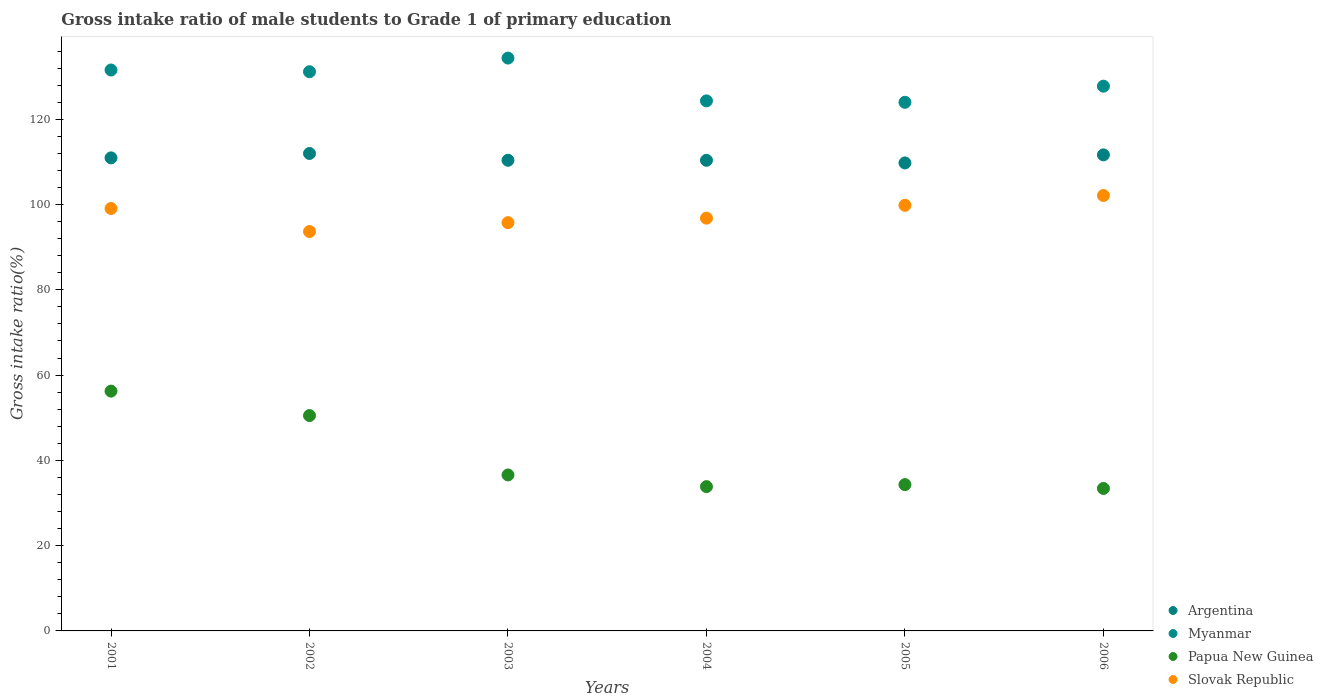How many different coloured dotlines are there?
Your response must be concise. 4. What is the gross intake ratio in Slovak Republic in 2005?
Offer a very short reply. 99.82. Across all years, what is the maximum gross intake ratio in Myanmar?
Offer a very short reply. 134.35. Across all years, what is the minimum gross intake ratio in Papua New Guinea?
Keep it short and to the point. 33.41. In which year was the gross intake ratio in Slovak Republic maximum?
Offer a very short reply. 2006. In which year was the gross intake ratio in Slovak Republic minimum?
Ensure brevity in your answer.  2002. What is the total gross intake ratio in Papua New Guinea in the graph?
Make the answer very short. 244.9. What is the difference between the gross intake ratio in Myanmar in 2002 and that in 2005?
Provide a succinct answer. 7.17. What is the difference between the gross intake ratio in Argentina in 2003 and the gross intake ratio in Myanmar in 2001?
Your answer should be compact. -21.17. What is the average gross intake ratio in Myanmar per year?
Provide a succinct answer. 128.85. In the year 2004, what is the difference between the gross intake ratio in Papua New Guinea and gross intake ratio in Slovak Republic?
Your answer should be very brief. -62.97. In how many years, is the gross intake ratio in Slovak Republic greater than 132 %?
Your response must be concise. 0. What is the ratio of the gross intake ratio in Myanmar in 2004 to that in 2005?
Your answer should be very brief. 1. What is the difference between the highest and the second highest gross intake ratio in Argentina?
Your answer should be very brief. 0.33. What is the difference between the highest and the lowest gross intake ratio in Slovak Republic?
Your answer should be compact. 8.45. In how many years, is the gross intake ratio in Myanmar greater than the average gross intake ratio in Myanmar taken over all years?
Offer a terse response. 3. Is the sum of the gross intake ratio in Papua New Guinea in 2002 and 2005 greater than the maximum gross intake ratio in Myanmar across all years?
Give a very brief answer. No. Is it the case that in every year, the sum of the gross intake ratio in Myanmar and gross intake ratio in Argentina  is greater than the sum of gross intake ratio in Slovak Republic and gross intake ratio in Papua New Guinea?
Your answer should be very brief. Yes. What is the difference between two consecutive major ticks on the Y-axis?
Ensure brevity in your answer.  20. Does the graph contain grids?
Provide a short and direct response. No. What is the title of the graph?
Offer a very short reply. Gross intake ratio of male students to Grade 1 of primary education. Does "Norway" appear as one of the legend labels in the graph?
Offer a very short reply. No. What is the label or title of the Y-axis?
Provide a short and direct response. Gross intake ratio(%). What is the Gross intake ratio(%) of Argentina in 2001?
Provide a short and direct response. 110.95. What is the Gross intake ratio(%) of Myanmar in 2001?
Ensure brevity in your answer.  131.56. What is the Gross intake ratio(%) of Papua New Guinea in 2001?
Keep it short and to the point. 56.24. What is the Gross intake ratio(%) in Slovak Republic in 2001?
Make the answer very short. 99.08. What is the Gross intake ratio(%) of Argentina in 2002?
Make the answer very short. 111.98. What is the Gross intake ratio(%) in Myanmar in 2002?
Offer a very short reply. 131.15. What is the Gross intake ratio(%) of Papua New Guinea in 2002?
Your response must be concise. 50.51. What is the Gross intake ratio(%) of Slovak Republic in 2002?
Provide a short and direct response. 93.67. What is the Gross intake ratio(%) in Argentina in 2003?
Ensure brevity in your answer.  110.39. What is the Gross intake ratio(%) in Myanmar in 2003?
Provide a succinct answer. 134.35. What is the Gross intake ratio(%) in Papua New Guinea in 2003?
Offer a terse response. 36.58. What is the Gross intake ratio(%) of Slovak Republic in 2003?
Give a very brief answer. 95.75. What is the Gross intake ratio(%) in Argentina in 2004?
Offer a terse response. 110.38. What is the Gross intake ratio(%) of Myanmar in 2004?
Give a very brief answer. 124.32. What is the Gross intake ratio(%) of Papua New Guinea in 2004?
Your response must be concise. 33.84. What is the Gross intake ratio(%) in Slovak Republic in 2004?
Provide a short and direct response. 96.81. What is the Gross intake ratio(%) of Argentina in 2005?
Offer a terse response. 109.76. What is the Gross intake ratio(%) in Myanmar in 2005?
Your answer should be very brief. 123.98. What is the Gross intake ratio(%) in Papua New Guinea in 2005?
Offer a very short reply. 34.31. What is the Gross intake ratio(%) of Slovak Republic in 2005?
Keep it short and to the point. 99.82. What is the Gross intake ratio(%) of Argentina in 2006?
Make the answer very short. 111.65. What is the Gross intake ratio(%) of Myanmar in 2006?
Give a very brief answer. 127.77. What is the Gross intake ratio(%) of Papua New Guinea in 2006?
Offer a very short reply. 33.41. What is the Gross intake ratio(%) of Slovak Republic in 2006?
Your answer should be compact. 102.12. Across all years, what is the maximum Gross intake ratio(%) in Argentina?
Provide a short and direct response. 111.98. Across all years, what is the maximum Gross intake ratio(%) of Myanmar?
Your answer should be compact. 134.35. Across all years, what is the maximum Gross intake ratio(%) in Papua New Guinea?
Your response must be concise. 56.24. Across all years, what is the maximum Gross intake ratio(%) in Slovak Republic?
Your response must be concise. 102.12. Across all years, what is the minimum Gross intake ratio(%) in Argentina?
Make the answer very short. 109.76. Across all years, what is the minimum Gross intake ratio(%) in Myanmar?
Keep it short and to the point. 123.98. Across all years, what is the minimum Gross intake ratio(%) in Papua New Guinea?
Your response must be concise. 33.41. Across all years, what is the minimum Gross intake ratio(%) in Slovak Republic?
Provide a short and direct response. 93.67. What is the total Gross intake ratio(%) in Argentina in the graph?
Give a very brief answer. 665.11. What is the total Gross intake ratio(%) of Myanmar in the graph?
Ensure brevity in your answer.  773.12. What is the total Gross intake ratio(%) of Papua New Guinea in the graph?
Provide a short and direct response. 244.9. What is the total Gross intake ratio(%) in Slovak Republic in the graph?
Offer a terse response. 587.25. What is the difference between the Gross intake ratio(%) of Argentina in 2001 and that in 2002?
Make the answer very short. -1.03. What is the difference between the Gross intake ratio(%) of Myanmar in 2001 and that in 2002?
Provide a succinct answer. 0.4. What is the difference between the Gross intake ratio(%) in Papua New Guinea in 2001 and that in 2002?
Ensure brevity in your answer.  5.73. What is the difference between the Gross intake ratio(%) of Slovak Republic in 2001 and that in 2002?
Your answer should be very brief. 5.41. What is the difference between the Gross intake ratio(%) of Argentina in 2001 and that in 2003?
Give a very brief answer. 0.56. What is the difference between the Gross intake ratio(%) in Myanmar in 2001 and that in 2003?
Provide a short and direct response. -2.8. What is the difference between the Gross intake ratio(%) in Papua New Guinea in 2001 and that in 2003?
Make the answer very short. 19.66. What is the difference between the Gross intake ratio(%) of Slovak Republic in 2001 and that in 2003?
Ensure brevity in your answer.  3.32. What is the difference between the Gross intake ratio(%) in Argentina in 2001 and that in 2004?
Make the answer very short. 0.57. What is the difference between the Gross intake ratio(%) in Myanmar in 2001 and that in 2004?
Offer a terse response. 7.24. What is the difference between the Gross intake ratio(%) in Papua New Guinea in 2001 and that in 2004?
Provide a succinct answer. 22.4. What is the difference between the Gross intake ratio(%) of Slovak Republic in 2001 and that in 2004?
Keep it short and to the point. 2.27. What is the difference between the Gross intake ratio(%) of Argentina in 2001 and that in 2005?
Provide a succinct answer. 1.19. What is the difference between the Gross intake ratio(%) in Myanmar in 2001 and that in 2005?
Your response must be concise. 7.57. What is the difference between the Gross intake ratio(%) of Papua New Guinea in 2001 and that in 2005?
Provide a succinct answer. 21.93. What is the difference between the Gross intake ratio(%) of Slovak Republic in 2001 and that in 2005?
Offer a terse response. -0.75. What is the difference between the Gross intake ratio(%) in Argentina in 2001 and that in 2006?
Provide a short and direct response. -0.7. What is the difference between the Gross intake ratio(%) in Myanmar in 2001 and that in 2006?
Your response must be concise. 3.79. What is the difference between the Gross intake ratio(%) in Papua New Guinea in 2001 and that in 2006?
Ensure brevity in your answer.  22.83. What is the difference between the Gross intake ratio(%) in Slovak Republic in 2001 and that in 2006?
Your answer should be compact. -3.05. What is the difference between the Gross intake ratio(%) in Argentina in 2002 and that in 2003?
Provide a short and direct response. 1.6. What is the difference between the Gross intake ratio(%) of Myanmar in 2002 and that in 2003?
Keep it short and to the point. -3.2. What is the difference between the Gross intake ratio(%) of Papua New Guinea in 2002 and that in 2003?
Your answer should be compact. 13.93. What is the difference between the Gross intake ratio(%) in Slovak Republic in 2002 and that in 2003?
Offer a very short reply. -2.08. What is the difference between the Gross intake ratio(%) in Argentina in 2002 and that in 2004?
Your response must be concise. 1.6. What is the difference between the Gross intake ratio(%) in Myanmar in 2002 and that in 2004?
Ensure brevity in your answer.  6.84. What is the difference between the Gross intake ratio(%) of Papua New Guinea in 2002 and that in 2004?
Give a very brief answer. 16.67. What is the difference between the Gross intake ratio(%) of Slovak Republic in 2002 and that in 2004?
Ensure brevity in your answer.  -3.14. What is the difference between the Gross intake ratio(%) of Argentina in 2002 and that in 2005?
Make the answer very short. 2.22. What is the difference between the Gross intake ratio(%) in Myanmar in 2002 and that in 2005?
Provide a short and direct response. 7.17. What is the difference between the Gross intake ratio(%) of Papua New Guinea in 2002 and that in 2005?
Make the answer very short. 16.2. What is the difference between the Gross intake ratio(%) of Slovak Republic in 2002 and that in 2005?
Provide a short and direct response. -6.15. What is the difference between the Gross intake ratio(%) in Argentina in 2002 and that in 2006?
Keep it short and to the point. 0.33. What is the difference between the Gross intake ratio(%) in Myanmar in 2002 and that in 2006?
Your answer should be compact. 3.39. What is the difference between the Gross intake ratio(%) in Papua New Guinea in 2002 and that in 2006?
Offer a terse response. 17.1. What is the difference between the Gross intake ratio(%) of Slovak Republic in 2002 and that in 2006?
Keep it short and to the point. -8.45. What is the difference between the Gross intake ratio(%) of Argentina in 2003 and that in 2004?
Your answer should be compact. 0.01. What is the difference between the Gross intake ratio(%) of Myanmar in 2003 and that in 2004?
Offer a terse response. 10.04. What is the difference between the Gross intake ratio(%) in Papua New Guinea in 2003 and that in 2004?
Offer a terse response. 2.74. What is the difference between the Gross intake ratio(%) in Slovak Republic in 2003 and that in 2004?
Make the answer very short. -1.06. What is the difference between the Gross intake ratio(%) of Argentina in 2003 and that in 2005?
Offer a very short reply. 0.63. What is the difference between the Gross intake ratio(%) of Myanmar in 2003 and that in 2005?
Provide a short and direct response. 10.37. What is the difference between the Gross intake ratio(%) in Papua New Guinea in 2003 and that in 2005?
Your answer should be compact. 2.27. What is the difference between the Gross intake ratio(%) in Slovak Republic in 2003 and that in 2005?
Offer a terse response. -4.07. What is the difference between the Gross intake ratio(%) in Argentina in 2003 and that in 2006?
Make the answer very short. -1.27. What is the difference between the Gross intake ratio(%) of Myanmar in 2003 and that in 2006?
Offer a terse response. 6.58. What is the difference between the Gross intake ratio(%) in Papua New Guinea in 2003 and that in 2006?
Your answer should be very brief. 3.17. What is the difference between the Gross intake ratio(%) of Slovak Republic in 2003 and that in 2006?
Keep it short and to the point. -6.37. What is the difference between the Gross intake ratio(%) of Argentina in 2004 and that in 2005?
Ensure brevity in your answer.  0.62. What is the difference between the Gross intake ratio(%) of Myanmar in 2004 and that in 2005?
Provide a short and direct response. 0.33. What is the difference between the Gross intake ratio(%) of Papua New Guinea in 2004 and that in 2005?
Keep it short and to the point. -0.47. What is the difference between the Gross intake ratio(%) in Slovak Republic in 2004 and that in 2005?
Provide a succinct answer. -3.01. What is the difference between the Gross intake ratio(%) in Argentina in 2004 and that in 2006?
Provide a succinct answer. -1.27. What is the difference between the Gross intake ratio(%) in Myanmar in 2004 and that in 2006?
Your answer should be very brief. -3.45. What is the difference between the Gross intake ratio(%) of Papua New Guinea in 2004 and that in 2006?
Ensure brevity in your answer.  0.43. What is the difference between the Gross intake ratio(%) of Slovak Republic in 2004 and that in 2006?
Keep it short and to the point. -5.31. What is the difference between the Gross intake ratio(%) of Argentina in 2005 and that in 2006?
Provide a short and direct response. -1.89. What is the difference between the Gross intake ratio(%) of Myanmar in 2005 and that in 2006?
Provide a short and direct response. -3.78. What is the difference between the Gross intake ratio(%) of Papua New Guinea in 2005 and that in 2006?
Ensure brevity in your answer.  0.9. What is the difference between the Gross intake ratio(%) of Slovak Republic in 2005 and that in 2006?
Give a very brief answer. -2.3. What is the difference between the Gross intake ratio(%) in Argentina in 2001 and the Gross intake ratio(%) in Myanmar in 2002?
Make the answer very short. -20.2. What is the difference between the Gross intake ratio(%) of Argentina in 2001 and the Gross intake ratio(%) of Papua New Guinea in 2002?
Provide a short and direct response. 60.44. What is the difference between the Gross intake ratio(%) of Argentina in 2001 and the Gross intake ratio(%) of Slovak Republic in 2002?
Ensure brevity in your answer.  17.28. What is the difference between the Gross intake ratio(%) of Myanmar in 2001 and the Gross intake ratio(%) of Papua New Guinea in 2002?
Your answer should be very brief. 81.04. What is the difference between the Gross intake ratio(%) of Myanmar in 2001 and the Gross intake ratio(%) of Slovak Republic in 2002?
Provide a succinct answer. 37.89. What is the difference between the Gross intake ratio(%) in Papua New Guinea in 2001 and the Gross intake ratio(%) in Slovak Republic in 2002?
Offer a terse response. -37.43. What is the difference between the Gross intake ratio(%) in Argentina in 2001 and the Gross intake ratio(%) in Myanmar in 2003?
Your response must be concise. -23.4. What is the difference between the Gross intake ratio(%) of Argentina in 2001 and the Gross intake ratio(%) of Papua New Guinea in 2003?
Your response must be concise. 74.37. What is the difference between the Gross intake ratio(%) of Argentina in 2001 and the Gross intake ratio(%) of Slovak Republic in 2003?
Keep it short and to the point. 15.2. What is the difference between the Gross intake ratio(%) of Myanmar in 2001 and the Gross intake ratio(%) of Papua New Guinea in 2003?
Offer a very short reply. 94.98. What is the difference between the Gross intake ratio(%) of Myanmar in 2001 and the Gross intake ratio(%) of Slovak Republic in 2003?
Your answer should be very brief. 35.8. What is the difference between the Gross intake ratio(%) of Papua New Guinea in 2001 and the Gross intake ratio(%) of Slovak Republic in 2003?
Provide a short and direct response. -39.51. What is the difference between the Gross intake ratio(%) of Argentina in 2001 and the Gross intake ratio(%) of Myanmar in 2004?
Offer a terse response. -13.37. What is the difference between the Gross intake ratio(%) of Argentina in 2001 and the Gross intake ratio(%) of Papua New Guinea in 2004?
Offer a terse response. 77.11. What is the difference between the Gross intake ratio(%) in Argentina in 2001 and the Gross intake ratio(%) in Slovak Republic in 2004?
Provide a succinct answer. 14.14. What is the difference between the Gross intake ratio(%) in Myanmar in 2001 and the Gross intake ratio(%) in Papua New Guinea in 2004?
Ensure brevity in your answer.  97.72. What is the difference between the Gross intake ratio(%) of Myanmar in 2001 and the Gross intake ratio(%) of Slovak Republic in 2004?
Offer a very short reply. 34.74. What is the difference between the Gross intake ratio(%) in Papua New Guinea in 2001 and the Gross intake ratio(%) in Slovak Republic in 2004?
Your answer should be compact. -40.57. What is the difference between the Gross intake ratio(%) in Argentina in 2001 and the Gross intake ratio(%) in Myanmar in 2005?
Make the answer very short. -13.03. What is the difference between the Gross intake ratio(%) in Argentina in 2001 and the Gross intake ratio(%) in Papua New Guinea in 2005?
Your answer should be very brief. 76.63. What is the difference between the Gross intake ratio(%) of Argentina in 2001 and the Gross intake ratio(%) of Slovak Republic in 2005?
Provide a succinct answer. 11.13. What is the difference between the Gross intake ratio(%) in Myanmar in 2001 and the Gross intake ratio(%) in Papua New Guinea in 2005?
Your response must be concise. 97.24. What is the difference between the Gross intake ratio(%) in Myanmar in 2001 and the Gross intake ratio(%) in Slovak Republic in 2005?
Ensure brevity in your answer.  31.73. What is the difference between the Gross intake ratio(%) in Papua New Guinea in 2001 and the Gross intake ratio(%) in Slovak Republic in 2005?
Ensure brevity in your answer.  -43.58. What is the difference between the Gross intake ratio(%) of Argentina in 2001 and the Gross intake ratio(%) of Myanmar in 2006?
Offer a very short reply. -16.82. What is the difference between the Gross intake ratio(%) of Argentina in 2001 and the Gross intake ratio(%) of Papua New Guinea in 2006?
Make the answer very short. 77.54. What is the difference between the Gross intake ratio(%) of Argentina in 2001 and the Gross intake ratio(%) of Slovak Republic in 2006?
Your response must be concise. 8.83. What is the difference between the Gross intake ratio(%) in Myanmar in 2001 and the Gross intake ratio(%) in Papua New Guinea in 2006?
Keep it short and to the point. 98.14. What is the difference between the Gross intake ratio(%) in Myanmar in 2001 and the Gross intake ratio(%) in Slovak Republic in 2006?
Give a very brief answer. 29.43. What is the difference between the Gross intake ratio(%) in Papua New Guinea in 2001 and the Gross intake ratio(%) in Slovak Republic in 2006?
Your response must be concise. -45.88. What is the difference between the Gross intake ratio(%) in Argentina in 2002 and the Gross intake ratio(%) in Myanmar in 2003?
Provide a succinct answer. -22.37. What is the difference between the Gross intake ratio(%) of Argentina in 2002 and the Gross intake ratio(%) of Papua New Guinea in 2003?
Provide a short and direct response. 75.4. What is the difference between the Gross intake ratio(%) of Argentina in 2002 and the Gross intake ratio(%) of Slovak Republic in 2003?
Provide a succinct answer. 16.23. What is the difference between the Gross intake ratio(%) in Myanmar in 2002 and the Gross intake ratio(%) in Papua New Guinea in 2003?
Keep it short and to the point. 94.57. What is the difference between the Gross intake ratio(%) in Myanmar in 2002 and the Gross intake ratio(%) in Slovak Republic in 2003?
Offer a terse response. 35.4. What is the difference between the Gross intake ratio(%) in Papua New Guinea in 2002 and the Gross intake ratio(%) in Slovak Republic in 2003?
Your response must be concise. -45.24. What is the difference between the Gross intake ratio(%) of Argentina in 2002 and the Gross intake ratio(%) of Myanmar in 2004?
Offer a very short reply. -12.33. What is the difference between the Gross intake ratio(%) of Argentina in 2002 and the Gross intake ratio(%) of Papua New Guinea in 2004?
Keep it short and to the point. 78.14. What is the difference between the Gross intake ratio(%) in Argentina in 2002 and the Gross intake ratio(%) in Slovak Republic in 2004?
Your answer should be very brief. 15.17. What is the difference between the Gross intake ratio(%) in Myanmar in 2002 and the Gross intake ratio(%) in Papua New Guinea in 2004?
Keep it short and to the point. 97.31. What is the difference between the Gross intake ratio(%) in Myanmar in 2002 and the Gross intake ratio(%) in Slovak Republic in 2004?
Provide a short and direct response. 34.34. What is the difference between the Gross intake ratio(%) in Papua New Guinea in 2002 and the Gross intake ratio(%) in Slovak Republic in 2004?
Provide a succinct answer. -46.3. What is the difference between the Gross intake ratio(%) of Argentina in 2002 and the Gross intake ratio(%) of Myanmar in 2005?
Provide a short and direct response. -12. What is the difference between the Gross intake ratio(%) in Argentina in 2002 and the Gross intake ratio(%) in Papua New Guinea in 2005?
Your answer should be compact. 77.67. What is the difference between the Gross intake ratio(%) in Argentina in 2002 and the Gross intake ratio(%) in Slovak Republic in 2005?
Keep it short and to the point. 12.16. What is the difference between the Gross intake ratio(%) of Myanmar in 2002 and the Gross intake ratio(%) of Papua New Guinea in 2005?
Your answer should be compact. 96.84. What is the difference between the Gross intake ratio(%) in Myanmar in 2002 and the Gross intake ratio(%) in Slovak Republic in 2005?
Your response must be concise. 31.33. What is the difference between the Gross intake ratio(%) in Papua New Guinea in 2002 and the Gross intake ratio(%) in Slovak Republic in 2005?
Your response must be concise. -49.31. What is the difference between the Gross intake ratio(%) in Argentina in 2002 and the Gross intake ratio(%) in Myanmar in 2006?
Give a very brief answer. -15.78. What is the difference between the Gross intake ratio(%) in Argentina in 2002 and the Gross intake ratio(%) in Papua New Guinea in 2006?
Offer a very short reply. 78.57. What is the difference between the Gross intake ratio(%) in Argentina in 2002 and the Gross intake ratio(%) in Slovak Republic in 2006?
Give a very brief answer. 9.86. What is the difference between the Gross intake ratio(%) in Myanmar in 2002 and the Gross intake ratio(%) in Papua New Guinea in 2006?
Provide a succinct answer. 97.74. What is the difference between the Gross intake ratio(%) of Myanmar in 2002 and the Gross intake ratio(%) of Slovak Republic in 2006?
Offer a terse response. 29.03. What is the difference between the Gross intake ratio(%) of Papua New Guinea in 2002 and the Gross intake ratio(%) of Slovak Republic in 2006?
Offer a terse response. -51.61. What is the difference between the Gross intake ratio(%) in Argentina in 2003 and the Gross intake ratio(%) in Myanmar in 2004?
Offer a terse response. -13.93. What is the difference between the Gross intake ratio(%) in Argentina in 2003 and the Gross intake ratio(%) in Papua New Guinea in 2004?
Offer a terse response. 76.55. What is the difference between the Gross intake ratio(%) of Argentina in 2003 and the Gross intake ratio(%) of Slovak Republic in 2004?
Offer a terse response. 13.58. What is the difference between the Gross intake ratio(%) in Myanmar in 2003 and the Gross intake ratio(%) in Papua New Guinea in 2004?
Your answer should be very brief. 100.51. What is the difference between the Gross intake ratio(%) in Myanmar in 2003 and the Gross intake ratio(%) in Slovak Republic in 2004?
Offer a terse response. 37.54. What is the difference between the Gross intake ratio(%) in Papua New Guinea in 2003 and the Gross intake ratio(%) in Slovak Republic in 2004?
Make the answer very short. -60.23. What is the difference between the Gross intake ratio(%) in Argentina in 2003 and the Gross intake ratio(%) in Myanmar in 2005?
Give a very brief answer. -13.59. What is the difference between the Gross intake ratio(%) of Argentina in 2003 and the Gross intake ratio(%) of Papua New Guinea in 2005?
Offer a terse response. 76.07. What is the difference between the Gross intake ratio(%) of Argentina in 2003 and the Gross intake ratio(%) of Slovak Republic in 2005?
Provide a short and direct response. 10.57. What is the difference between the Gross intake ratio(%) in Myanmar in 2003 and the Gross intake ratio(%) in Papua New Guinea in 2005?
Provide a short and direct response. 100.04. What is the difference between the Gross intake ratio(%) of Myanmar in 2003 and the Gross intake ratio(%) of Slovak Republic in 2005?
Provide a short and direct response. 34.53. What is the difference between the Gross intake ratio(%) in Papua New Guinea in 2003 and the Gross intake ratio(%) in Slovak Republic in 2005?
Ensure brevity in your answer.  -63.24. What is the difference between the Gross intake ratio(%) of Argentina in 2003 and the Gross intake ratio(%) of Myanmar in 2006?
Provide a short and direct response. -17.38. What is the difference between the Gross intake ratio(%) in Argentina in 2003 and the Gross intake ratio(%) in Papua New Guinea in 2006?
Ensure brevity in your answer.  76.97. What is the difference between the Gross intake ratio(%) of Argentina in 2003 and the Gross intake ratio(%) of Slovak Republic in 2006?
Your answer should be very brief. 8.26. What is the difference between the Gross intake ratio(%) of Myanmar in 2003 and the Gross intake ratio(%) of Papua New Guinea in 2006?
Give a very brief answer. 100.94. What is the difference between the Gross intake ratio(%) of Myanmar in 2003 and the Gross intake ratio(%) of Slovak Republic in 2006?
Ensure brevity in your answer.  32.23. What is the difference between the Gross intake ratio(%) of Papua New Guinea in 2003 and the Gross intake ratio(%) of Slovak Republic in 2006?
Your answer should be compact. -65.54. What is the difference between the Gross intake ratio(%) in Argentina in 2004 and the Gross intake ratio(%) in Myanmar in 2005?
Your response must be concise. -13.6. What is the difference between the Gross intake ratio(%) in Argentina in 2004 and the Gross intake ratio(%) in Papua New Guinea in 2005?
Your response must be concise. 76.06. What is the difference between the Gross intake ratio(%) of Argentina in 2004 and the Gross intake ratio(%) of Slovak Republic in 2005?
Keep it short and to the point. 10.56. What is the difference between the Gross intake ratio(%) in Myanmar in 2004 and the Gross intake ratio(%) in Papua New Guinea in 2005?
Give a very brief answer. 90. What is the difference between the Gross intake ratio(%) in Myanmar in 2004 and the Gross intake ratio(%) in Slovak Republic in 2005?
Make the answer very short. 24.49. What is the difference between the Gross intake ratio(%) in Papua New Guinea in 2004 and the Gross intake ratio(%) in Slovak Republic in 2005?
Provide a succinct answer. -65.98. What is the difference between the Gross intake ratio(%) in Argentina in 2004 and the Gross intake ratio(%) in Myanmar in 2006?
Give a very brief answer. -17.39. What is the difference between the Gross intake ratio(%) of Argentina in 2004 and the Gross intake ratio(%) of Papua New Guinea in 2006?
Your response must be concise. 76.97. What is the difference between the Gross intake ratio(%) in Argentina in 2004 and the Gross intake ratio(%) in Slovak Republic in 2006?
Give a very brief answer. 8.26. What is the difference between the Gross intake ratio(%) in Myanmar in 2004 and the Gross intake ratio(%) in Papua New Guinea in 2006?
Offer a very short reply. 90.9. What is the difference between the Gross intake ratio(%) in Myanmar in 2004 and the Gross intake ratio(%) in Slovak Republic in 2006?
Make the answer very short. 22.19. What is the difference between the Gross intake ratio(%) of Papua New Guinea in 2004 and the Gross intake ratio(%) of Slovak Republic in 2006?
Offer a very short reply. -68.28. What is the difference between the Gross intake ratio(%) in Argentina in 2005 and the Gross intake ratio(%) in Myanmar in 2006?
Ensure brevity in your answer.  -18.01. What is the difference between the Gross intake ratio(%) of Argentina in 2005 and the Gross intake ratio(%) of Papua New Guinea in 2006?
Offer a very short reply. 76.35. What is the difference between the Gross intake ratio(%) in Argentina in 2005 and the Gross intake ratio(%) in Slovak Republic in 2006?
Offer a very short reply. 7.64. What is the difference between the Gross intake ratio(%) in Myanmar in 2005 and the Gross intake ratio(%) in Papua New Guinea in 2006?
Make the answer very short. 90.57. What is the difference between the Gross intake ratio(%) in Myanmar in 2005 and the Gross intake ratio(%) in Slovak Republic in 2006?
Provide a short and direct response. 21.86. What is the difference between the Gross intake ratio(%) of Papua New Guinea in 2005 and the Gross intake ratio(%) of Slovak Republic in 2006?
Your response must be concise. -67.81. What is the average Gross intake ratio(%) in Argentina per year?
Make the answer very short. 110.85. What is the average Gross intake ratio(%) of Myanmar per year?
Provide a succinct answer. 128.85. What is the average Gross intake ratio(%) of Papua New Guinea per year?
Make the answer very short. 40.82. What is the average Gross intake ratio(%) in Slovak Republic per year?
Your answer should be very brief. 97.88. In the year 2001, what is the difference between the Gross intake ratio(%) in Argentina and Gross intake ratio(%) in Myanmar?
Offer a very short reply. -20.61. In the year 2001, what is the difference between the Gross intake ratio(%) in Argentina and Gross intake ratio(%) in Papua New Guinea?
Make the answer very short. 54.71. In the year 2001, what is the difference between the Gross intake ratio(%) of Argentina and Gross intake ratio(%) of Slovak Republic?
Offer a terse response. 11.87. In the year 2001, what is the difference between the Gross intake ratio(%) of Myanmar and Gross intake ratio(%) of Papua New Guinea?
Ensure brevity in your answer.  75.31. In the year 2001, what is the difference between the Gross intake ratio(%) in Myanmar and Gross intake ratio(%) in Slovak Republic?
Offer a very short reply. 32.48. In the year 2001, what is the difference between the Gross intake ratio(%) in Papua New Guinea and Gross intake ratio(%) in Slovak Republic?
Your answer should be compact. -42.83. In the year 2002, what is the difference between the Gross intake ratio(%) in Argentina and Gross intake ratio(%) in Myanmar?
Your answer should be very brief. -19.17. In the year 2002, what is the difference between the Gross intake ratio(%) in Argentina and Gross intake ratio(%) in Papua New Guinea?
Keep it short and to the point. 61.47. In the year 2002, what is the difference between the Gross intake ratio(%) of Argentina and Gross intake ratio(%) of Slovak Republic?
Make the answer very short. 18.31. In the year 2002, what is the difference between the Gross intake ratio(%) of Myanmar and Gross intake ratio(%) of Papua New Guinea?
Your answer should be compact. 80.64. In the year 2002, what is the difference between the Gross intake ratio(%) of Myanmar and Gross intake ratio(%) of Slovak Republic?
Offer a very short reply. 37.48. In the year 2002, what is the difference between the Gross intake ratio(%) in Papua New Guinea and Gross intake ratio(%) in Slovak Republic?
Provide a short and direct response. -43.16. In the year 2003, what is the difference between the Gross intake ratio(%) of Argentina and Gross intake ratio(%) of Myanmar?
Give a very brief answer. -23.96. In the year 2003, what is the difference between the Gross intake ratio(%) in Argentina and Gross intake ratio(%) in Papua New Guinea?
Your answer should be compact. 73.81. In the year 2003, what is the difference between the Gross intake ratio(%) of Argentina and Gross intake ratio(%) of Slovak Republic?
Your answer should be compact. 14.63. In the year 2003, what is the difference between the Gross intake ratio(%) of Myanmar and Gross intake ratio(%) of Papua New Guinea?
Ensure brevity in your answer.  97.77. In the year 2003, what is the difference between the Gross intake ratio(%) in Myanmar and Gross intake ratio(%) in Slovak Republic?
Make the answer very short. 38.6. In the year 2003, what is the difference between the Gross intake ratio(%) of Papua New Guinea and Gross intake ratio(%) of Slovak Republic?
Your response must be concise. -59.17. In the year 2004, what is the difference between the Gross intake ratio(%) in Argentina and Gross intake ratio(%) in Myanmar?
Give a very brief answer. -13.94. In the year 2004, what is the difference between the Gross intake ratio(%) in Argentina and Gross intake ratio(%) in Papua New Guinea?
Make the answer very short. 76.54. In the year 2004, what is the difference between the Gross intake ratio(%) of Argentina and Gross intake ratio(%) of Slovak Republic?
Offer a very short reply. 13.57. In the year 2004, what is the difference between the Gross intake ratio(%) in Myanmar and Gross intake ratio(%) in Papua New Guinea?
Keep it short and to the point. 90.48. In the year 2004, what is the difference between the Gross intake ratio(%) of Myanmar and Gross intake ratio(%) of Slovak Republic?
Ensure brevity in your answer.  27.51. In the year 2004, what is the difference between the Gross intake ratio(%) in Papua New Guinea and Gross intake ratio(%) in Slovak Republic?
Give a very brief answer. -62.97. In the year 2005, what is the difference between the Gross intake ratio(%) in Argentina and Gross intake ratio(%) in Myanmar?
Ensure brevity in your answer.  -14.22. In the year 2005, what is the difference between the Gross intake ratio(%) of Argentina and Gross intake ratio(%) of Papua New Guinea?
Your response must be concise. 75.45. In the year 2005, what is the difference between the Gross intake ratio(%) in Argentina and Gross intake ratio(%) in Slovak Republic?
Keep it short and to the point. 9.94. In the year 2005, what is the difference between the Gross intake ratio(%) in Myanmar and Gross intake ratio(%) in Papua New Guinea?
Keep it short and to the point. 89.67. In the year 2005, what is the difference between the Gross intake ratio(%) in Myanmar and Gross intake ratio(%) in Slovak Republic?
Your answer should be very brief. 24.16. In the year 2005, what is the difference between the Gross intake ratio(%) of Papua New Guinea and Gross intake ratio(%) of Slovak Republic?
Provide a short and direct response. -65.51. In the year 2006, what is the difference between the Gross intake ratio(%) of Argentina and Gross intake ratio(%) of Myanmar?
Provide a succinct answer. -16.11. In the year 2006, what is the difference between the Gross intake ratio(%) in Argentina and Gross intake ratio(%) in Papua New Guinea?
Your answer should be very brief. 78.24. In the year 2006, what is the difference between the Gross intake ratio(%) of Argentina and Gross intake ratio(%) of Slovak Republic?
Your response must be concise. 9.53. In the year 2006, what is the difference between the Gross intake ratio(%) of Myanmar and Gross intake ratio(%) of Papua New Guinea?
Ensure brevity in your answer.  94.35. In the year 2006, what is the difference between the Gross intake ratio(%) of Myanmar and Gross intake ratio(%) of Slovak Republic?
Offer a very short reply. 25.64. In the year 2006, what is the difference between the Gross intake ratio(%) of Papua New Guinea and Gross intake ratio(%) of Slovak Republic?
Keep it short and to the point. -68.71. What is the ratio of the Gross intake ratio(%) in Papua New Guinea in 2001 to that in 2002?
Offer a very short reply. 1.11. What is the ratio of the Gross intake ratio(%) of Slovak Republic in 2001 to that in 2002?
Offer a very short reply. 1.06. What is the ratio of the Gross intake ratio(%) of Myanmar in 2001 to that in 2003?
Ensure brevity in your answer.  0.98. What is the ratio of the Gross intake ratio(%) in Papua New Guinea in 2001 to that in 2003?
Offer a very short reply. 1.54. What is the ratio of the Gross intake ratio(%) in Slovak Republic in 2001 to that in 2003?
Give a very brief answer. 1.03. What is the ratio of the Gross intake ratio(%) in Myanmar in 2001 to that in 2004?
Provide a succinct answer. 1.06. What is the ratio of the Gross intake ratio(%) in Papua New Guinea in 2001 to that in 2004?
Ensure brevity in your answer.  1.66. What is the ratio of the Gross intake ratio(%) of Slovak Republic in 2001 to that in 2004?
Provide a succinct answer. 1.02. What is the ratio of the Gross intake ratio(%) in Argentina in 2001 to that in 2005?
Ensure brevity in your answer.  1.01. What is the ratio of the Gross intake ratio(%) of Myanmar in 2001 to that in 2005?
Your answer should be very brief. 1.06. What is the ratio of the Gross intake ratio(%) of Papua New Guinea in 2001 to that in 2005?
Your answer should be very brief. 1.64. What is the ratio of the Gross intake ratio(%) of Slovak Republic in 2001 to that in 2005?
Ensure brevity in your answer.  0.99. What is the ratio of the Gross intake ratio(%) in Argentina in 2001 to that in 2006?
Your answer should be compact. 0.99. What is the ratio of the Gross intake ratio(%) in Myanmar in 2001 to that in 2006?
Offer a terse response. 1.03. What is the ratio of the Gross intake ratio(%) of Papua New Guinea in 2001 to that in 2006?
Give a very brief answer. 1.68. What is the ratio of the Gross intake ratio(%) of Slovak Republic in 2001 to that in 2006?
Offer a terse response. 0.97. What is the ratio of the Gross intake ratio(%) of Argentina in 2002 to that in 2003?
Offer a terse response. 1.01. What is the ratio of the Gross intake ratio(%) in Myanmar in 2002 to that in 2003?
Your answer should be compact. 0.98. What is the ratio of the Gross intake ratio(%) in Papua New Guinea in 2002 to that in 2003?
Your response must be concise. 1.38. What is the ratio of the Gross intake ratio(%) of Slovak Republic in 2002 to that in 2003?
Your answer should be compact. 0.98. What is the ratio of the Gross intake ratio(%) of Argentina in 2002 to that in 2004?
Ensure brevity in your answer.  1.01. What is the ratio of the Gross intake ratio(%) in Myanmar in 2002 to that in 2004?
Your answer should be very brief. 1.05. What is the ratio of the Gross intake ratio(%) of Papua New Guinea in 2002 to that in 2004?
Your response must be concise. 1.49. What is the ratio of the Gross intake ratio(%) of Slovak Republic in 2002 to that in 2004?
Offer a terse response. 0.97. What is the ratio of the Gross intake ratio(%) in Argentina in 2002 to that in 2005?
Give a very brief answer. 1.02. What is the ratio of the Gross intake ratio(%) of Myanmar in 2002 to that in 2005?
Offer a terse response. 1.06. What is the ratio of the Gross intake ratio(%) in Papua New Guinea in 2002 to that in 2005?
Keep it short and to the point. 1.47. What is the ratio of the Gross intake ratio(%) in Slovak Republic in 2002 to that in 2005?
Offer a very short reply. 0.94. What is the ratio of the Gross intake ratio(%) of Argentina in 2002 to that in 2006?
Provide a short and direct response. 1. What is the ratio of the Gross intake ratio(%) in Myanmar in 2002 to that in 2006?
Your answer should be very brief. 1.03. What is the ratio of the Gross intake ratio(%) of Papua New Guinea in 2002 to that in 2006?
Keep it short and to the point. 1.51. What is the ratio of the Gross intake ratio(%) in Slovak Republic in 2002 to that in 2006?
Provide a succinct answer. 0.92. What is the ratio of the Gross intake ratio(%) of Myanmar in 2003 to that in 2004?
Offer a very short reply. 1.08. What is the ratio of the Gross intake ratio(%) of Papua New Guinea in 2003 to that in 2004?
Offer a terse response. 1.08. What is the ratio of the Gross intake ratio(%) of Slovak Republic in 2003 to that in 2004?
Give a very brief answer. 0.99. What is the ratio of the Gross intake ratio(%) of Myanmar in 2003 to that in 2005?
Provide a short and direct response. 1.08. What is the ratio of the Gross intake ratio(%) of Papua New Guinea in 2003 to that in 2005?
Ensure brevity in your answer.  1.07. What is the ratio of the Gross intake ratio(%) of Slovak Republic in 2003 to that in 2005?
Your answer should be compact. 0.96. What is the ratio of the Gross intake ratio(%) of Argentina in 2003 to that in 2006?
Make the answer very short. 0.99. What is the ratio of the Gross intake ratio(%) of Myanmar in 2003 to that in 2006?
Your answer should be very brief. 1.05. What is the ratio of the Gross intake ratio(%) of Papua New Guinea in 2003 to that in 2006?
Offer a terse response. 1.09. What is the ratio of the Gross intake ratio(%) of Slovak Republic in 2003 to that in 2006?
Your answer should be compact. 0.94. What is the ratio of the Gross intake ratio(%) in Argentina in 2004 to that in 2005?
Provide a short and direct response. 1.01. What is the ratio of the Gross intake ratio(%) of Papua New Guinea in 2004 to that in 2005?
Ensure brevity in your answer.  0.99. What is the ratio of the Gross intake ratio(%) of Slovak Republic in 2004 to that in 2005?
Ensure brevity in your answer.  0.97. What is the ratio of the Gross intake ratio(%) of Myanmar in 2004 to that in 2006?
Ensure brevity in your answer.  0.97. What is the ratio of the Gross intake ratio(%) in Papua New Guinea in 2004 to that in 2006?
Provide a succinct answer. 1.01. What is the ratio of the Gross intake ratio(%) in Slovak Republic in 2004 to that in 2006?
Offer a very short reply. 0.95. What is the ratio of the Gross intake ratio(%) of Argentina in 2005 to that in 2006?
Provide a succinct answer. 0.98. What is the ratio of the Gross intake ratio(%) of Myanmar in 2005 to that in 2006?
Offer a terse response. 0.97. What is the ratio of the Gross intake ratio(%) of Slovak Republic in 2005 to that in 2006?
Ensure brevity in your answer.  0.98. What is the difference between the highest and the second highest Gross intake ratio(%) in Argentina?
Keep it short and to the point. 0.33. What is the difference between the highest and the second highest Gross intake ratio(%) in Myanmar?
Keep it short and to the point. 2.8. What is the difference between the highest and the second highest Gross intake ratio(%) in Papua New Guinea?
Provide a succinct answer. 5.73. What is the difference between the highest and the second highest Gross intake ratio(%) of Slovak Republic?
Your answer should be very brief. 2.3. What is the difference between the highest and the lowest Gross intake ratio(%) in Argentina?
Your response must be concise. 2.22. What is the difference between the highest and the lowest Gross intake ratio(%) of Myanmar?
Offer a terse response. 10.37. What is the difference between the highest and the lowest Gross intake ratio(%) of Papua New Guinea?
Make the answer very short. 22.83. What is the difference between the highest and the lowest Gross intake ratio(%) in Slovak Republic?
Make the answer very short. 8.45. 